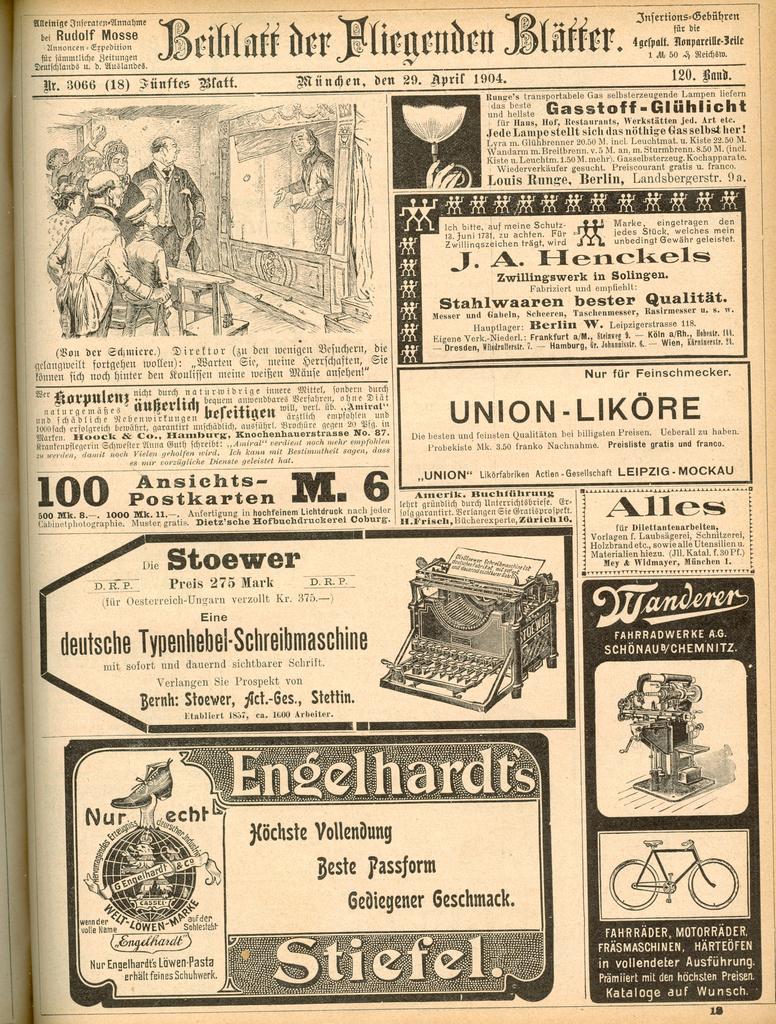What year is printed at the top?
Ensure brevity in your answer.  1904. What is the number to the middle left?
Ensure brevity in your answer.  100. 